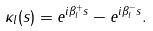Convert formula to latex. <formula><loc_0><loc_0><loc_500><loc_500>\kappa _ { l } ( s ) = e ^ { i \beta _ { l } ^ { + } s } - e ^ { i \beta _ { l } ^ { - } s } .</formula> 